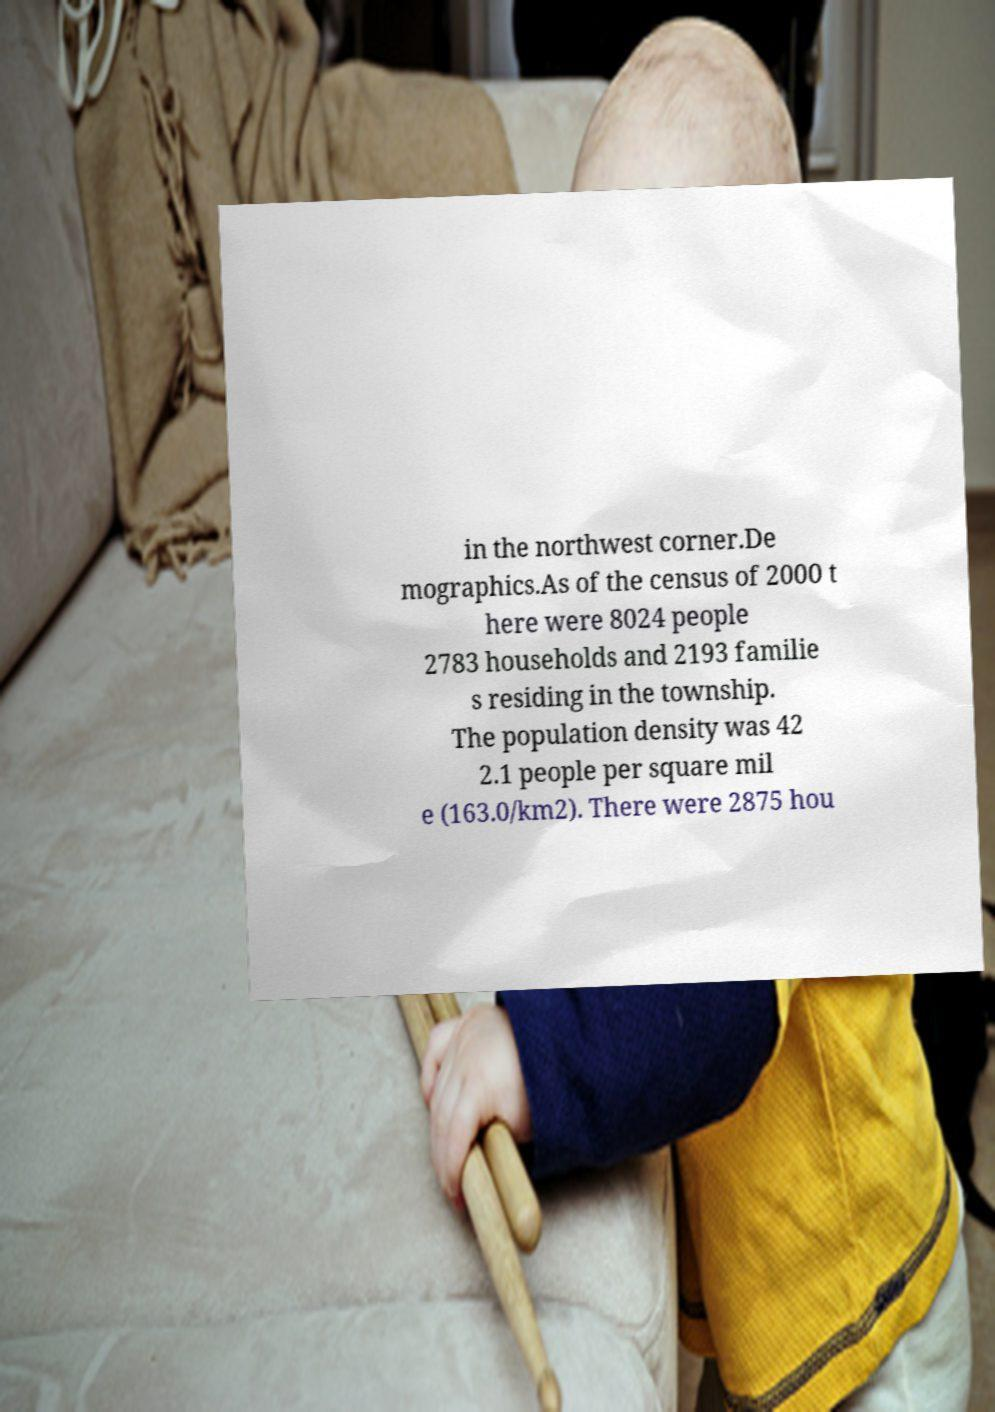Can you read and provide the text displayed in the image?This photo seems to have some interesting text. Can you extract and type it out for me? in the northwest corner.De mographics.As of the census of 2000 t here were 8024 people 2783 households and 2193 familie s residing in the township. The population density was 42 2.1 people per square mil e (163.0/km2). There were 2875 hou 